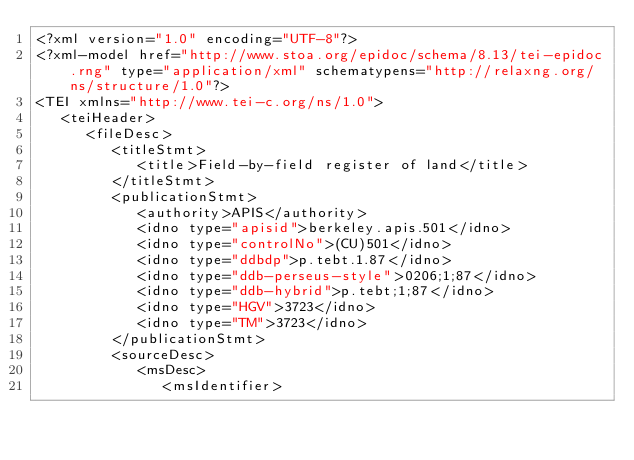<code> <loc_0><loc_0><loc_500><loc_500><_XML_><?xml version="1.0" encoding="UTF-8"?>
<?xml-model href="http://www.stoa.org/epidoc/schema/8.13/tei-epidoc.rng" type="application/xml" schematypens="http://relaxng.org/ns/structure/1.0"?>
<TEI xmlns="http://www.tei-c.org/ns/1.0">
   <teiHeader>
      <fileDesc>
         <titleStmt>
            <title>Field-by-field register of land</title>
         </titleStmt>
         <publicationStmt>
            <authority>APIS</authority>
            <idno type="apisid">berkeley.apis.501</idno>
            <idno type="controlNo">(CU)501</idno>
            <idno type="ddbdp">p.tebt.1.87</idno>
            <idno type="ddb-perseus-style">0206;1;87</idno>
            <idno type="ddb-hybrid">p.tebt;1;87</idno>
            <idno type="HGV">3723</idno>
            <idno type="TM">3723</idno>
         </publicationStmt>
         <sourceDesc>
            <msDesc>
               <msIdentifier></code> 